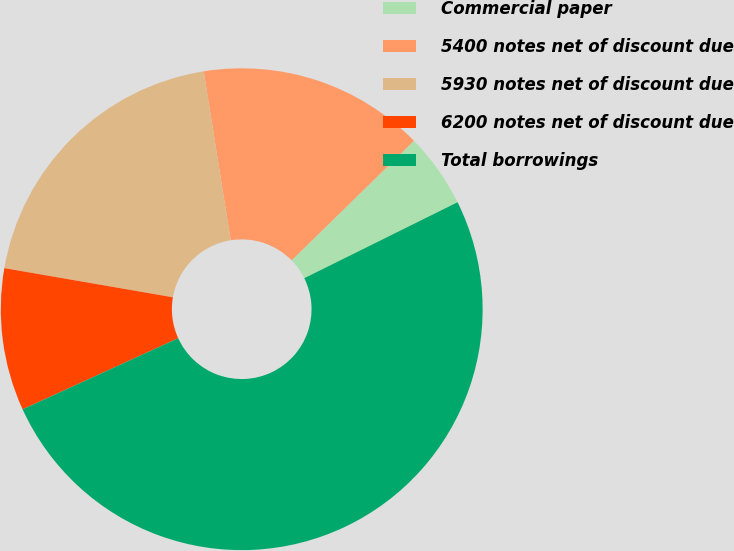Convert chart. <chart><loc_0><loc_0><loc_500><loc_500><pie_chart><fcel>Commercial paper<fcel>5400 notes net of discount due<fcel>5930 notes net of discount due<fcel>6200 notes net of discount due<fcel>Total borrowings<nl><fcel>5.0%<fcel>15.2%<fcel>19.75%<fcel>9.55%<fcel>50.5%<nl></chart> 